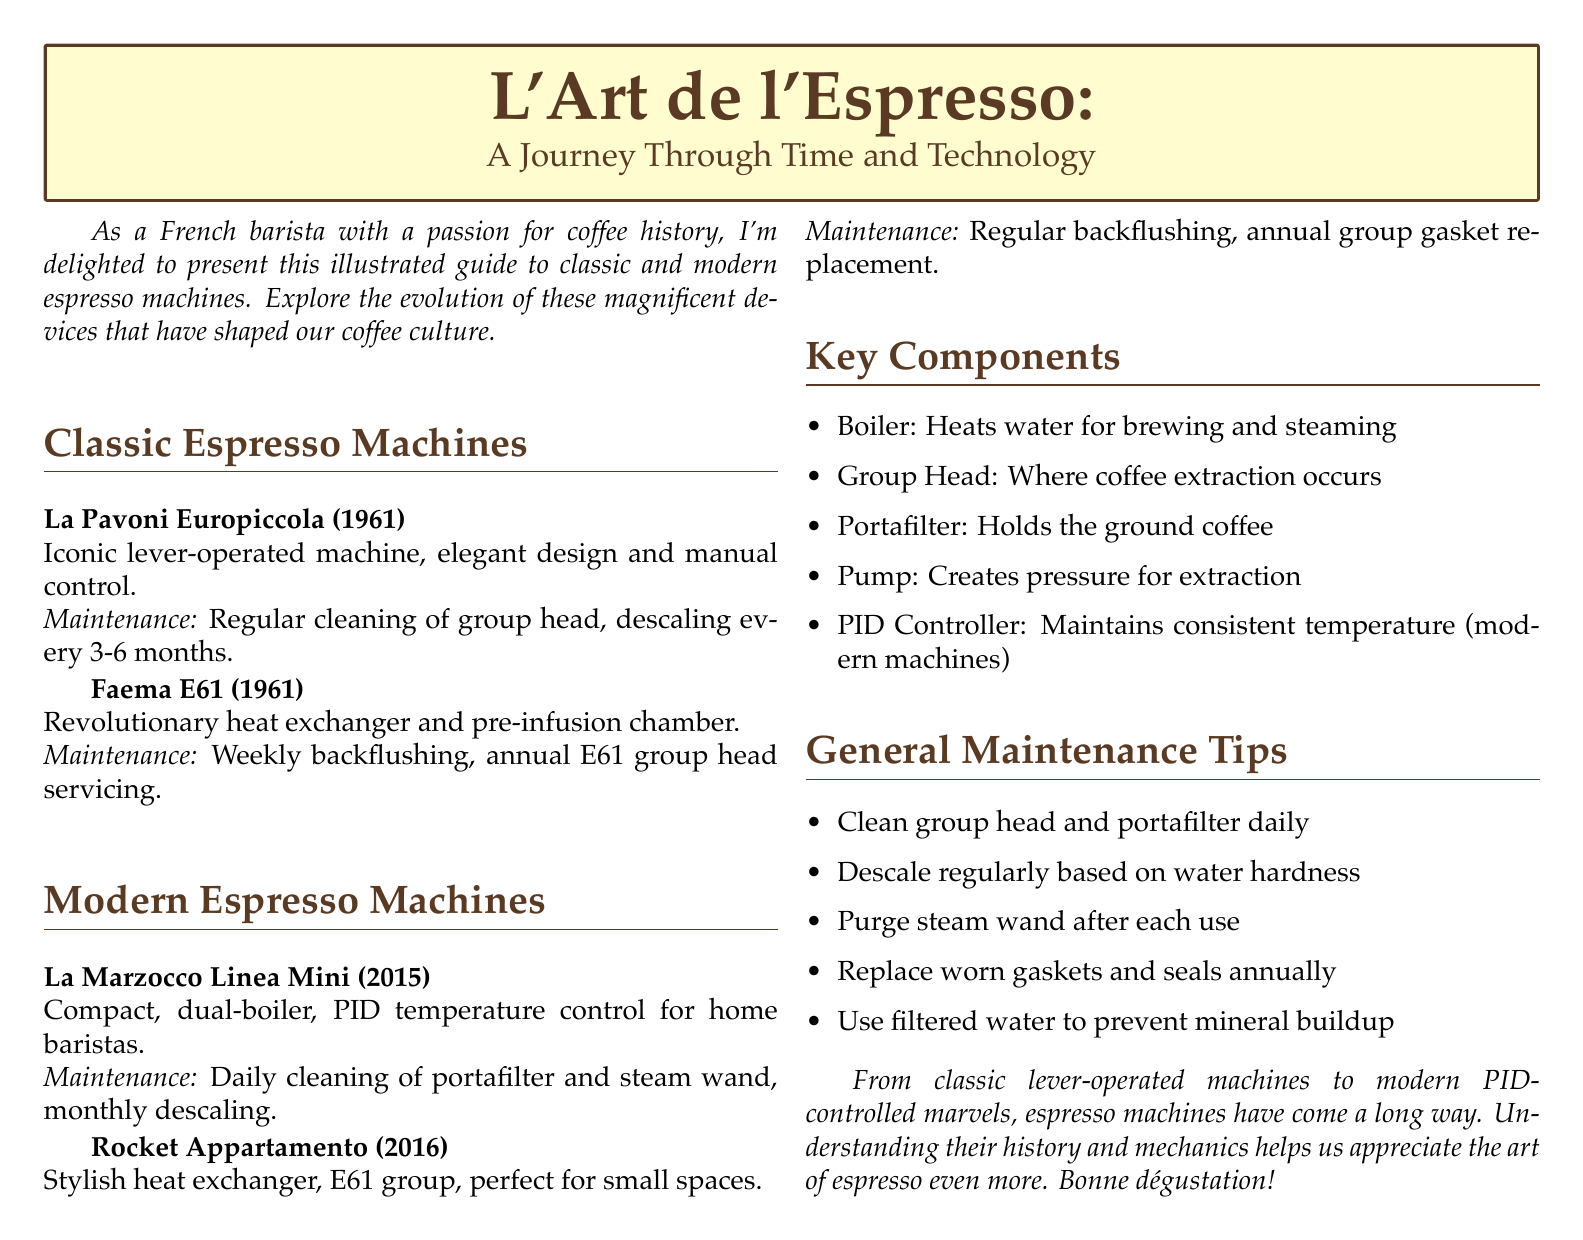What is the model of the classic lever-operated machine introduced in 1961? The document lists the La Pavoni Europiccola as the iconic lever-operated machine from 1961.
Answer: La Pavoni Europiccola What year was the Faema E61 released? The Faema E61 is noted in the document as being released in 1961.
Answer: 1961 What is a maintenance tip for the La Marzocco Linea Mini? The document mentions daily cleaning of the portafilter and steam wand as a maintenance tip for this model.
Answer: Daily cleaning of portafilter and steam wand What feature differentiates modern espresso machines from classic ones? The modern machines often include a PID controller to maintain consistent temperature, which is not mentioned for classic machines.
Answer: PID Controller How often should the group head of the Faema E61 be serviced? According to the document, the E61 group head should be serviced annually.
Answer: Annual What is the primary function of the pump in an espresso machine? The document states that the pump creates pressure for extraction.
Answer: Creates pressure for extraction What type of water is recommended for use in espresso machines? The document advises using filtered water to prevent mineral buildup.
Answer: Filtered water Which modern espresso machine is described as compact with PID temperature control? The document references the La Marzocco Linea Mini as the compact machine with PID temperature control.
Answer: La Marzocco Linea Mini 